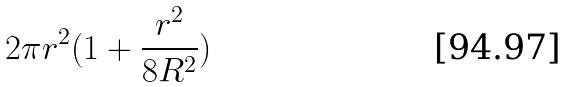<formula> <loc_0><loc_0><loc_500><loc_500>2 \pi r ^ { 2 } ( 1 + \frac { r ^ { 2 } } { 8 R ^ { 2 } } )</formula> 